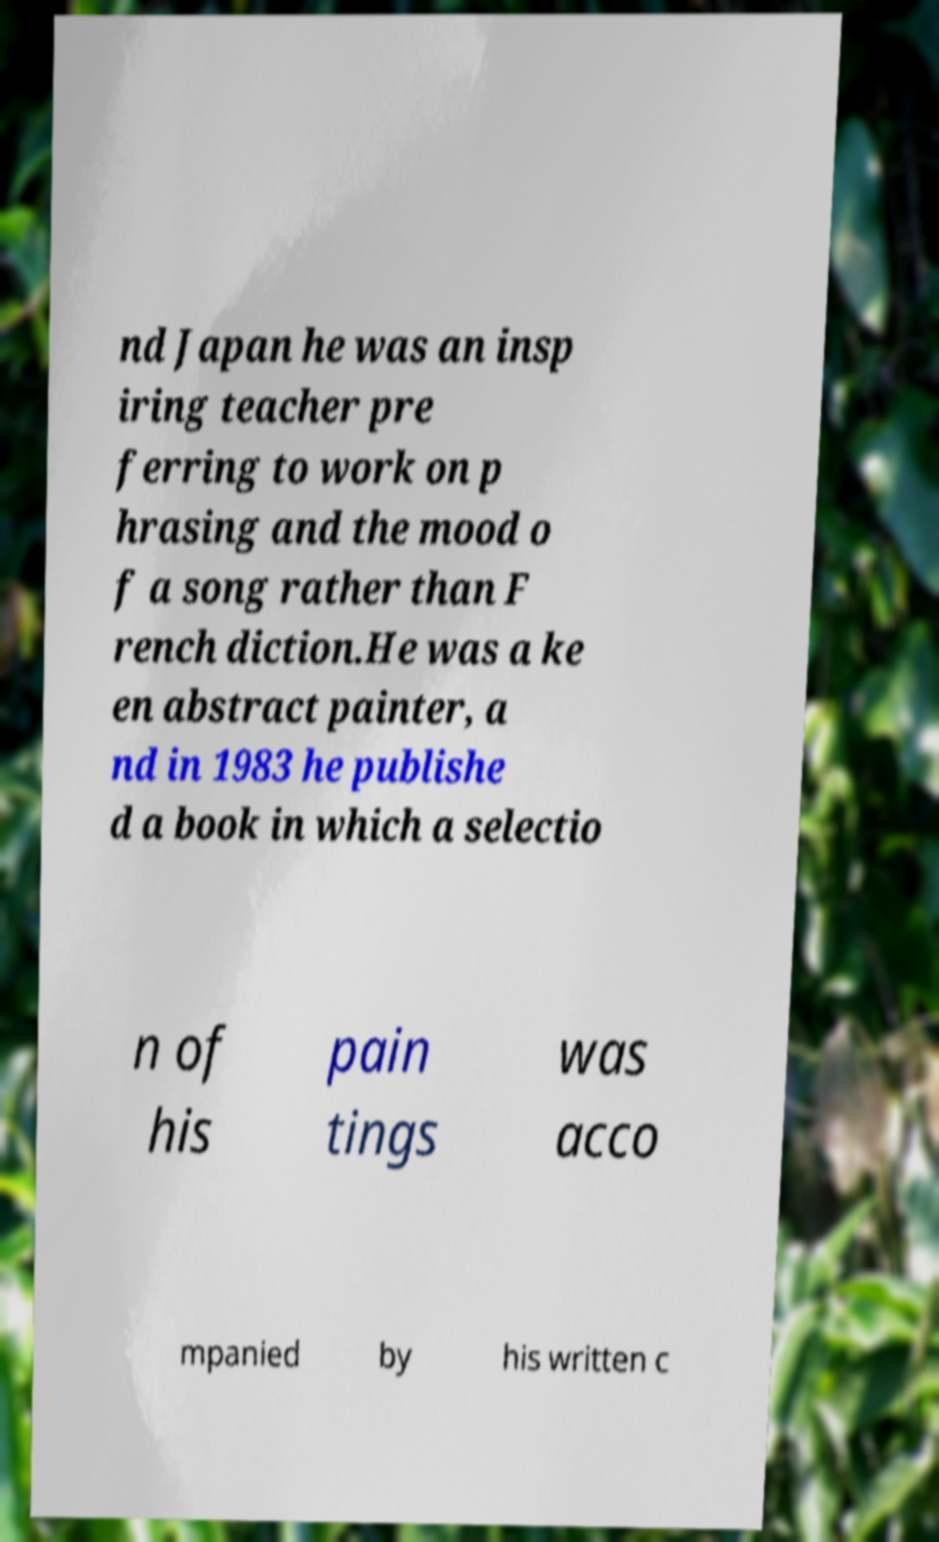Please identify and transcribe the text found in this image. nd Japan he was an insp iring teacher pre ferring to work on p hrasing and the mood o f a song rather than F rench diction.He was a ke en abstract painter, a nd in 1983 he publishe d a book in which a selectio n of his pain tings was acco mpanied by his written c 